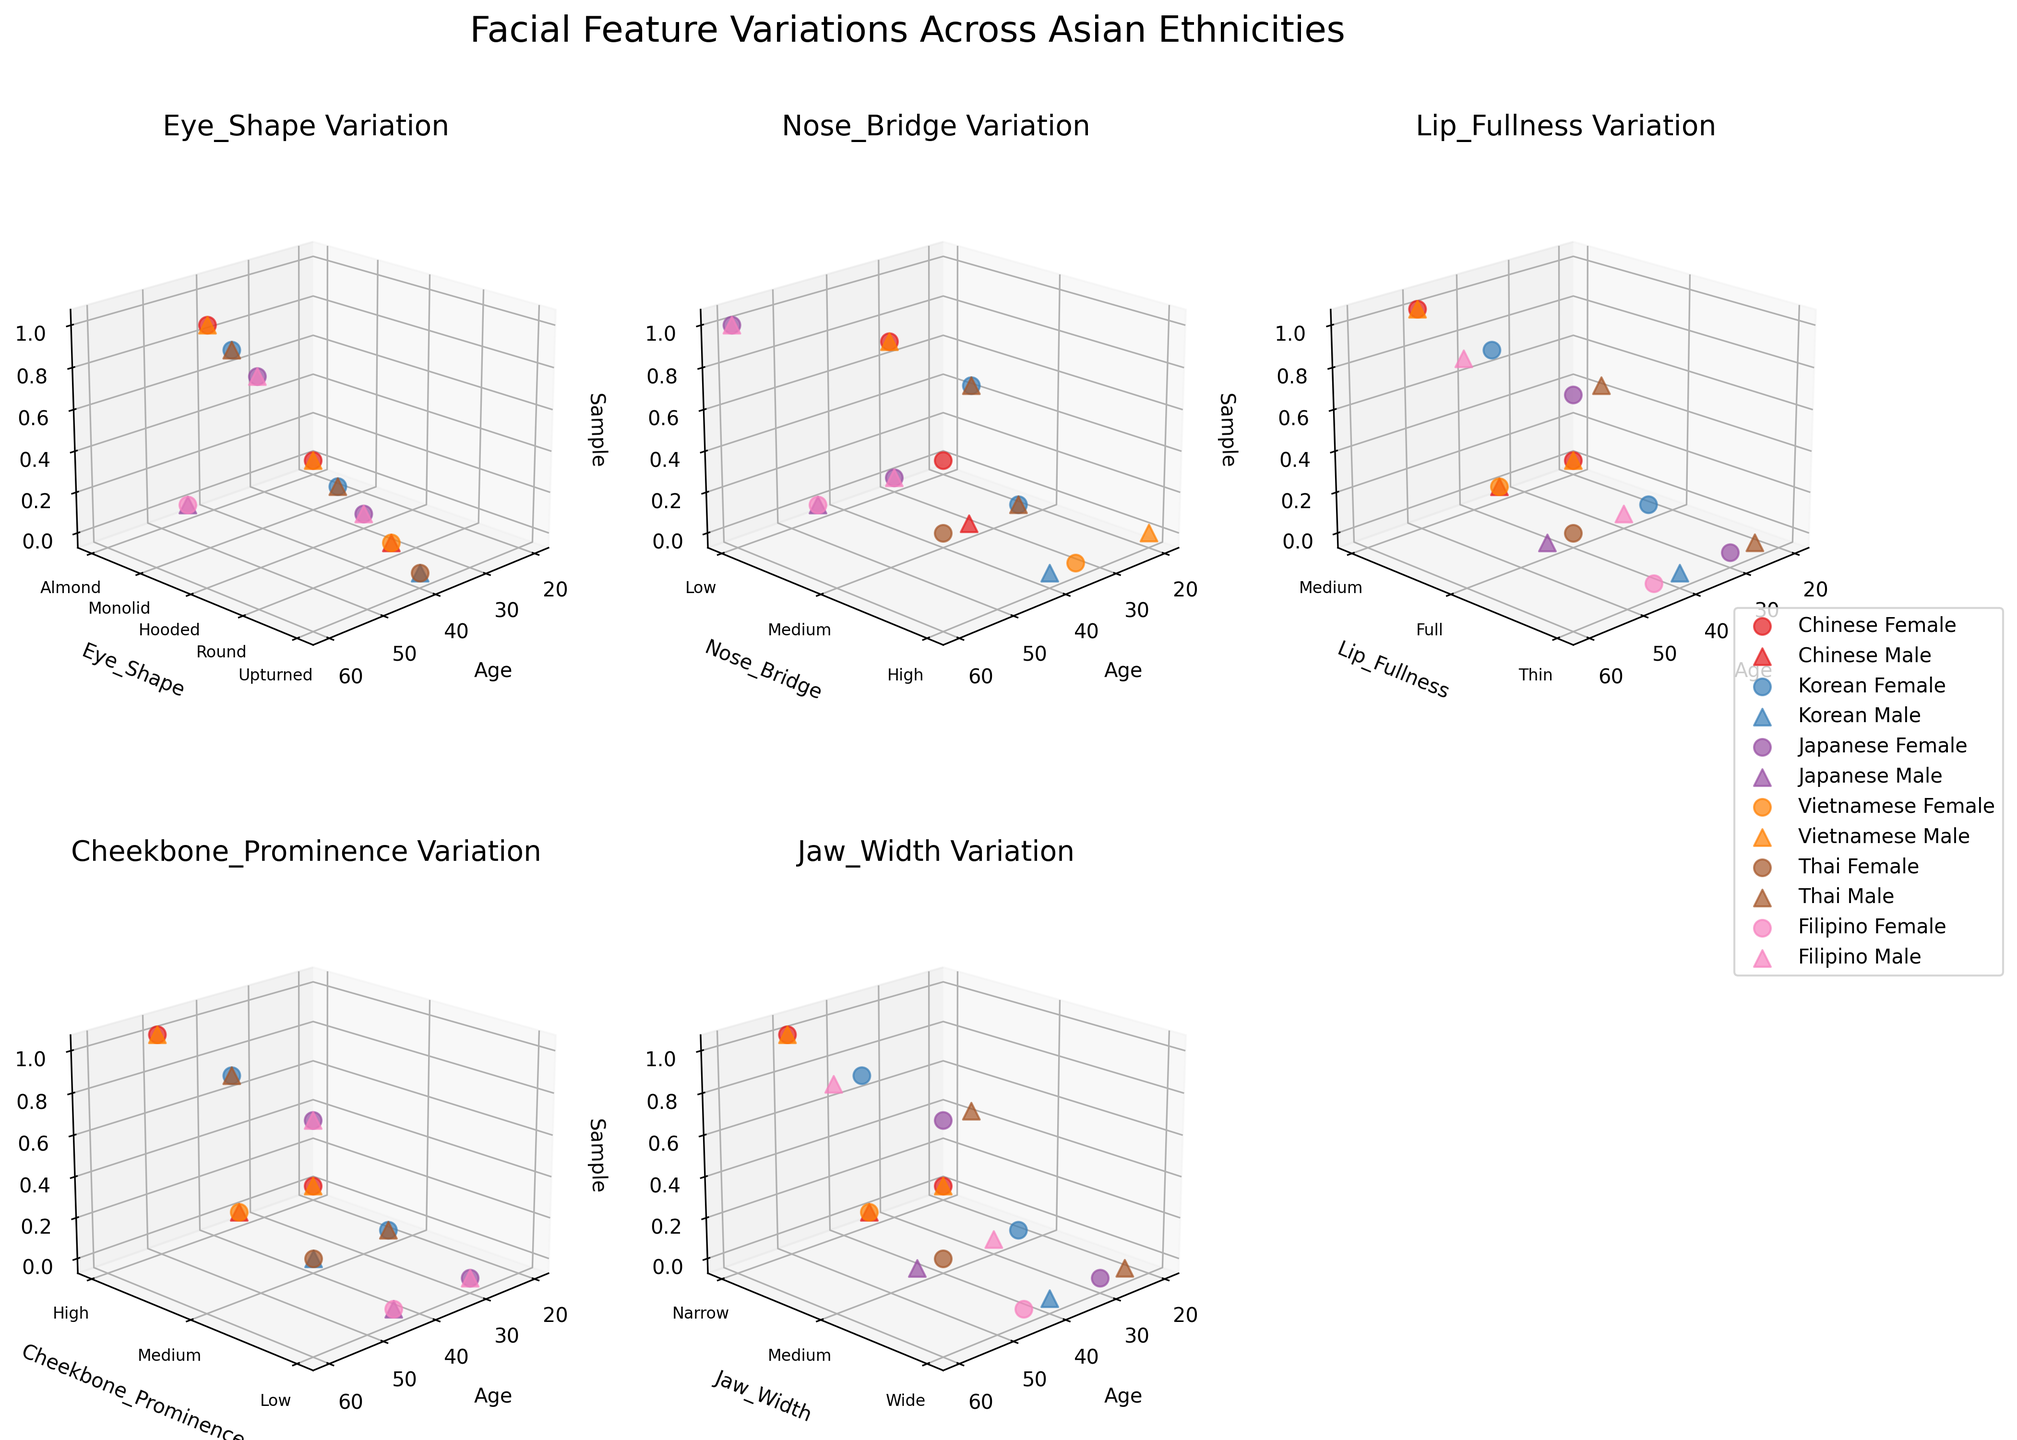What's the highest Cheekbone Prominence for Filipino females? Look at the subplot titled "Cheekbone Prominence Variation" and identify the data points for Filipino females. The Cheekbone Prominence for Filipino females is represented on the y-axis by the height of the markers. Based on the y-axis labels and the marker positions, determine the highest value.
Answer: Low How do Korean males and females compare in terms of Nose Bridge variation? Locate the subplot titled "Nose Bridge Variation" and focus on the Korean data points. For males (marker '^') and females (marker 'o'), observe the y-axis Noise Bridge values across different ages. Compare the trend lines of both genders for Korean Nose Bridge values.
Answer: Females: Low to High, Males: Medium to High Which ethnicity has the most variations in Eye Shape for males? In the "Eye Shape Variation" subplot, focus on the male markers ('^') for each ethnicity. Count the distinct Eye Shape categories (y-axis labels) each ethnicity covers. Determine which ethnicity spans the most categories.
Answer: Thai Is the Lip Fullness feature generally higher in females than in males? Refer to the "Lip Fullness Variation" subplot and compare female (o) and male (^) markers' y-axis values across all ethnicities and ages. Generally, evaluate if female data points tend to have higher y-axis values than male data points.
Answer: Yes Which feature shows a dramatic change with age for Japanese females? Analyze each subplot for Japanese females, noting how each feature (Eye Shape, Nose Bridge, Lip Fullness, Cheekbone Prominence, Jaw Width) changes along the age x-axis. Identify the feature with the most significant variance in y-axis values as age increases.
Answer: Eye Shape What is the most common Lip Fullness category for Thai individuals? Check the "Lip Fullness Variation" subplot and count y-axis labels corresponding to Thai markers (both genders). Identify the Lip Fullness category with the most Thai markers.
Answer: Thin Does Cheekbone Prominence show more variation in older or younger Vietnamese males? In the "Cheekbone Prominence Variation" subplot, locate Vietnamese male markers. Compare the spread of y-axis values for younger (20-40) versus older (45-60) age groups by discernible variance in y-axis values.
Answer: Older Which features appear to have no significant gender difference for Korean individuals? Study all subplots and focus on Korean markers. Inspect the gaps between male (^) and female (o) markers on the y-axis for each feature. Identify features where both genders overlap frequently.
Answer: Jaw Width How does Nose Bridge variation for Chinese males compare to Chinese females? Observe the "Nose Bridge Variation" subplot, focusing on the Chinese data points. Compare the range of y-axis values covered by male (^) and female (o) markers. Note differences in y-axis spread and levels.
Answer: Similar, Medium to High for both 